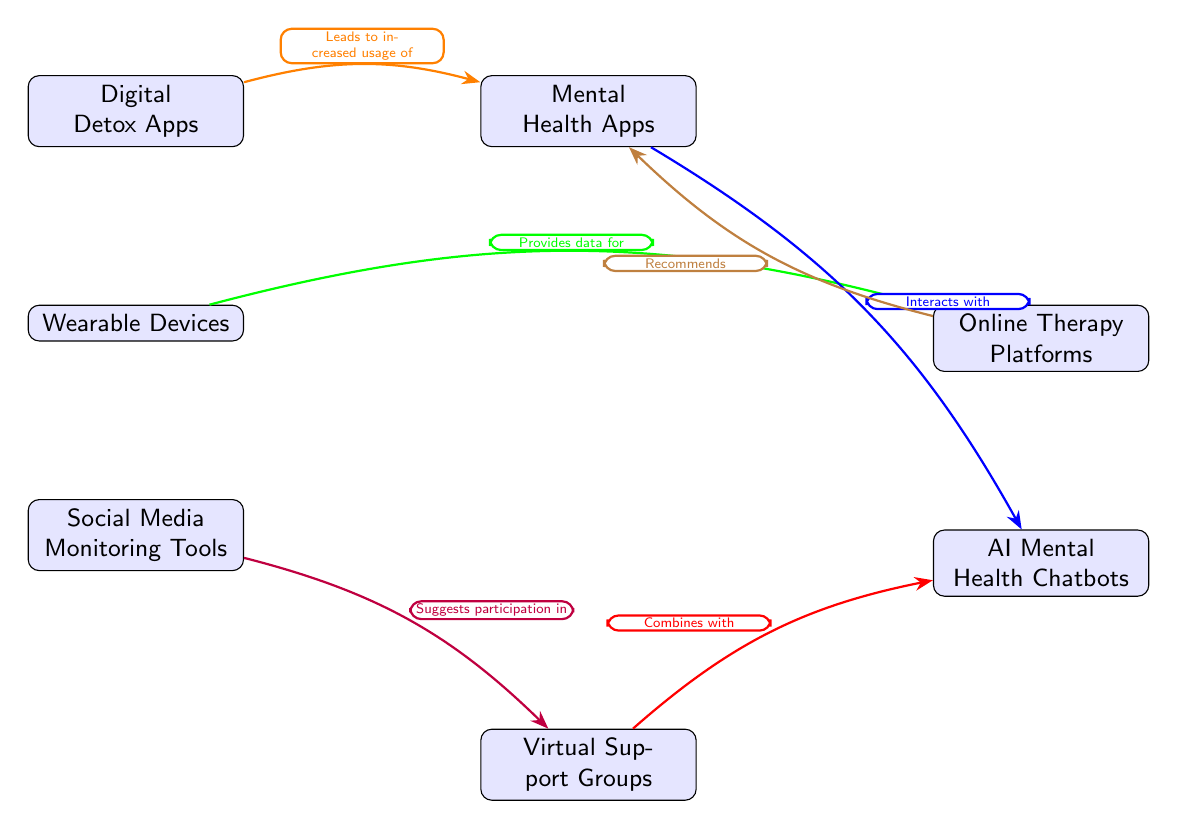What is the top node in the diagram? The top node, which represents the primary category in the ecosystem, is "Mental Health Apps."
Answer: Mental Health Apps How many nodes are present in the diagram? By counting the nodes: Mental Health Apps, Wearable Devices, Online Therapy Platforms, Social Media Monitoring Tools, Digital Detox Apps, Virtual Support Groups, and AI Mental Health Chatbots, we find there are 7 nodes in total.
Answer: 7 Which node is directly below "Mental Health Apps"? "Wearable Devices" and "Online Therapy Platforms" are positioned directly below "Mental Health Apps."
Answer: Wearable Devices, Online Therapy Platforms What relationship does "Digital Detox Apps" have with "Mental Health Apps"? "Digital Detox Apps" leads to increased usage of "Mental Health Apps," indicating a positive influence or correlation between the two nodes.
Answer: Leads to increased usage of Which node provides data for "Online Therapy Platforms"? "Wearable Devices" provides data for "Online Therapy Platforms," suggesting a direct connection in terms of data support between these two tools.
Answer: Wearable Devices How many edges are connecting the nodes in the diagram? There are six edges connecting the nodes, as indicated by the arrows shown in the diagram.
Answer: 6 What does "Social Media Monitoring Tools" suggest participation in? "Social Media Monitoring Tools" suggests participation in "Virtual Support Groups," indicating that engaging with monitoring tools can encourage joining support groups.
Answer: Virtual Support Groups What is the interaction between "Mental Health Apps" and "AI Mental Health Chatbots"? "Mental Health Apps" interacts with "AI Mental Health Chatbots," meaning there is a connection or feedback loop between these two elements in mental health technology.
Answer: Interacts with What does "Virtual Support Groups" combine with? "Virtual Support Groups" combines with "AI Mental Health Chatbots," indicating a collaborative relationship between these support systems.
Answer: Combines with 